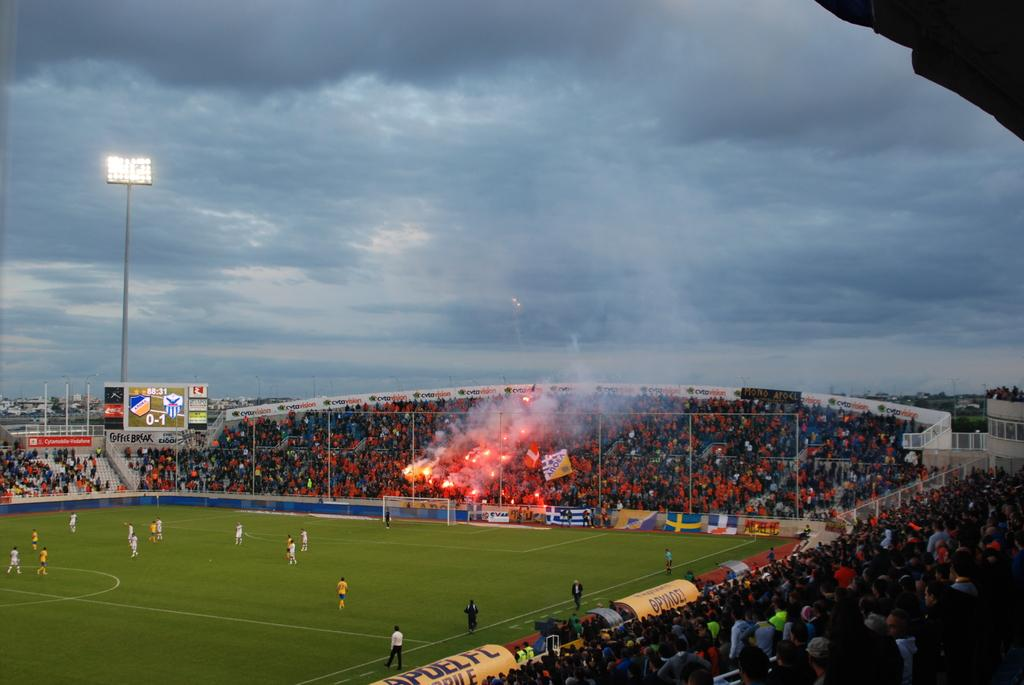<image>
Give a short and clear explanation of the subsequent image. A soccer match with the score 0 to 1 is being watched by many people. 